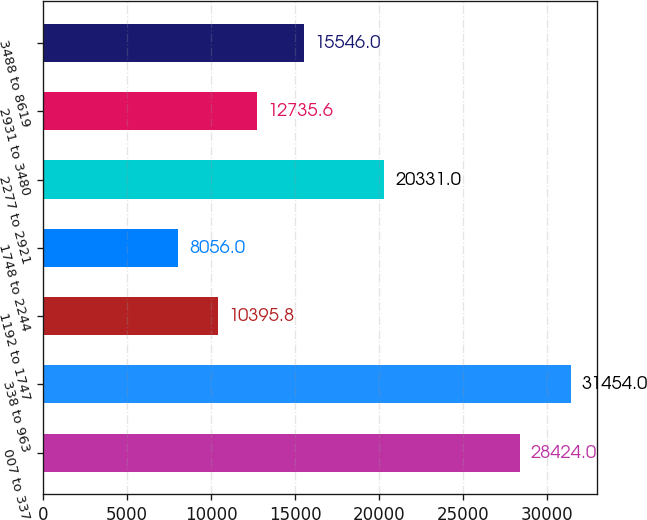Convert chart to OTSL. <chart><loc_0><loc_0><loc_500><loc_500><bar_chart><fcel>007 to 337<fcel>338 to 963<fcel>1192 to 1747<fcel>1748 to 2244<fcel>2277 to 2921<fcel>2931 to 3480<fcel>3488 to 8619<nl><fcel>28424<fcel>31454<fcel>10395.8<fcel>8056<fcel>20331<fcel>12735.6<fcel>15546<nl></chart> 